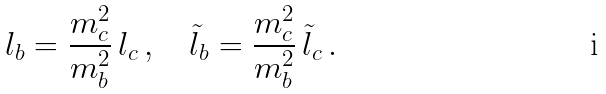Convert formula to latex. <formula><loc_0><loc_0><loc_500><loc_500>l _ { b } = \frac { m _ { c } ^ { 2 } } { m _ { b } ^ { 2 } } \, l _ { c } \, , \quad \tilde { l } _ { b } = \frac { m _ { c } ^ { 2 } } { m _ { b } ^ { 2 } } \, \tilde { l } _ { c } \, .</formula> 